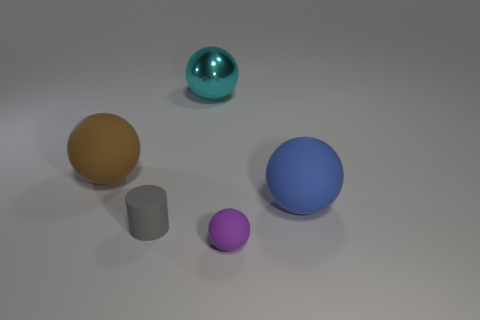Subtract all purple rubber spheres. How many spheres are left? 3 Subtract all gray spheres. Subtract all brown blocks. How many spheres are left? 4 Add 1 brown spheres. How many objects exist? 6 Subtract all cylinders. How many objects are left? 4 Add 1 cyan metallic balls. How many cyan metallic balls are left? 2 Add 2 cyan metal spheres. How many cyan metal spheres exist? 3 Subtract 1 blue balls. How many objects are left? 4 Subtract all large yellow things. Subtract all brown matte objects. How many objects are left? 4 